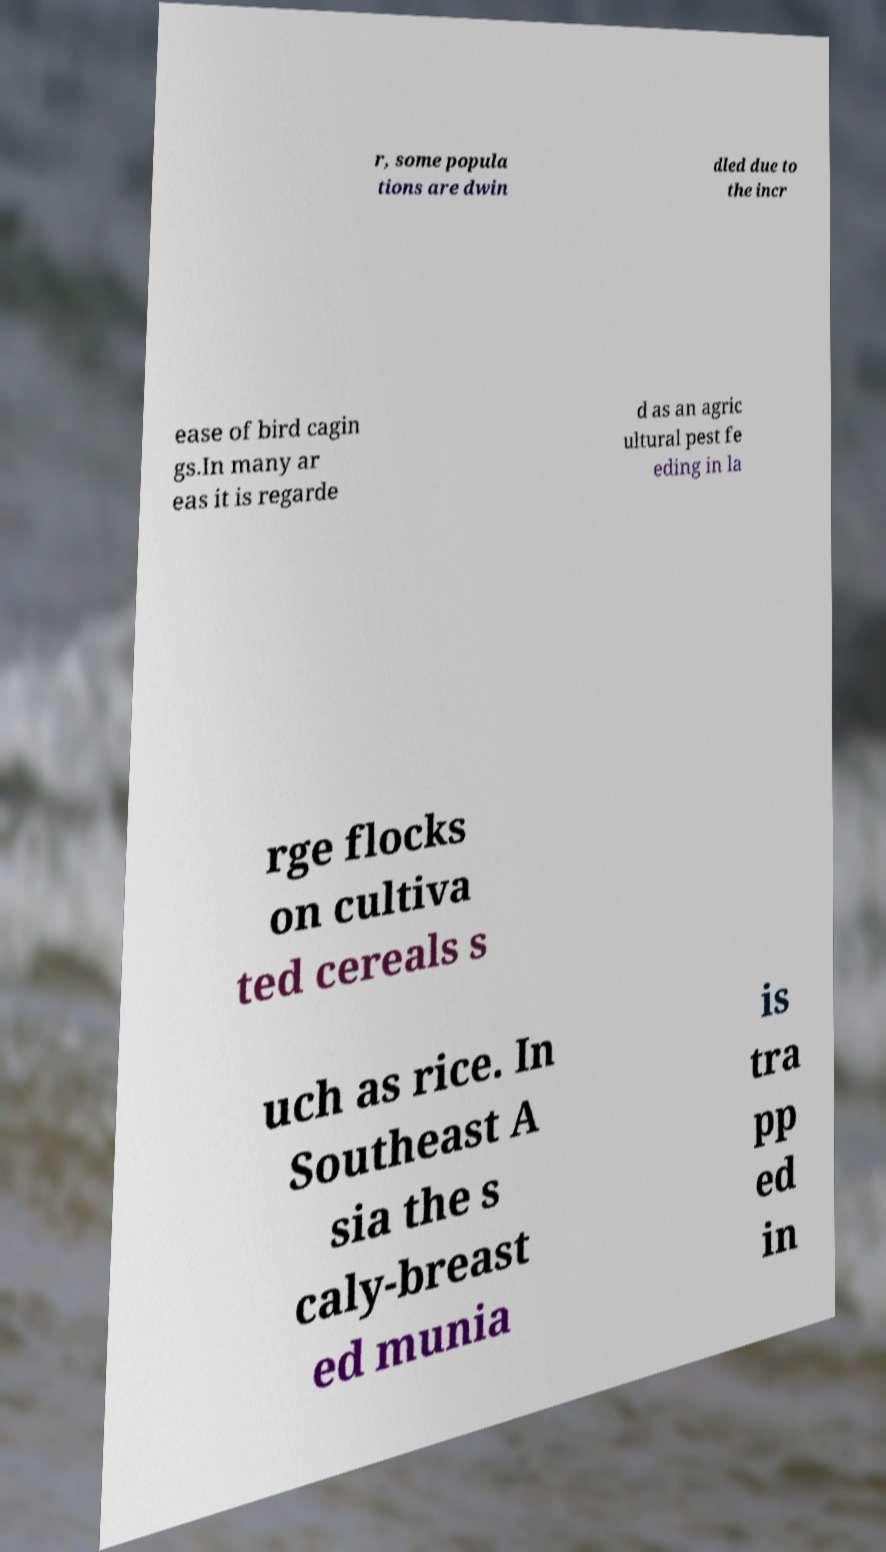Could you assist in decoding the text presented in this image and type it out clearly? r, some popula tions are dwin dled due to the incr ease of bird cagin gs.In many ar eas it is regarde d as an agric ultural pest fe eding in la rge flocks on cultiva ted cereals s uch as rice. In Southeast A sia the s caly-breast ed munia is tra pp ed in 